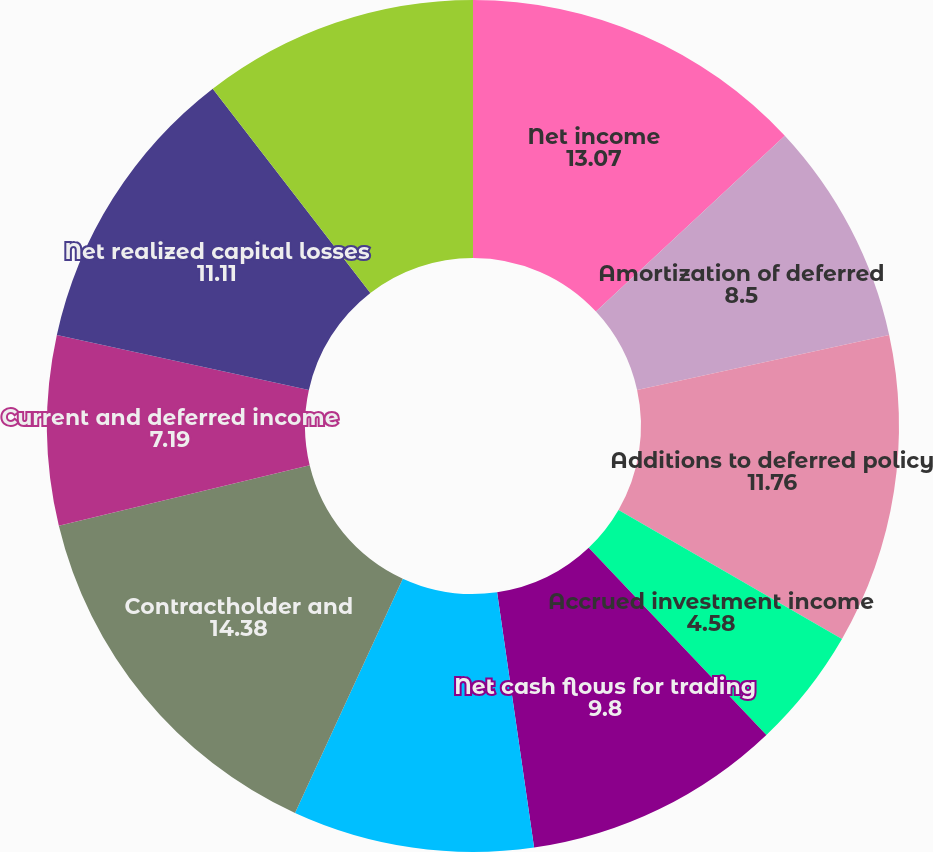<chart> <loc_0><loc_0><loc_500><loc_500><pie_chart><fcel>Net income<fcel>Amortization of deferred<fcel>Additions to deferred policy<fcel>Accrued investment income<fcel>Net cash flows for trading<fcel>Premiums due and other<fcel>Contractholder and<fcel>Current and deferred income<fcel>Net realized capital losses<fcel>Depreciation and amortization<nl><fcel>13.07%<fcel>8.5%<fcel>11.76%<fcel>4.58%<fcel>9.8%<fcel>9.15%<fcel>14.38%<fcel>7.19%<fcel>11.11%<fcel>10.46%<nl></chart> 